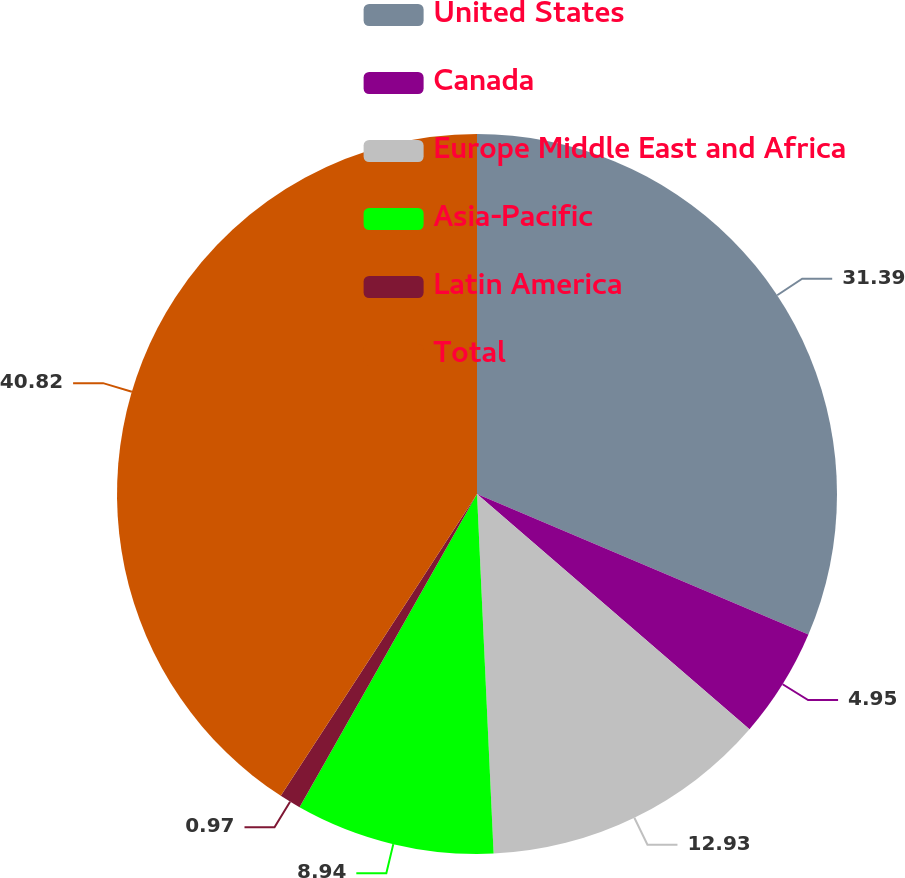<chart> <loc_0><loc_0><loc_500><loc_500><pie_chart><fcel>United States<fcel>Canada<fcel>Europe Middle East and Africa<fcel>Asia-Pacific<fcel>Latin America<fcel>Total<nl><fcel>31.39%<fcel>4.95%<fcel>12.93%<fcel>8.94%<fcel>0.97%<fcel>40.83%<nl></chart> 